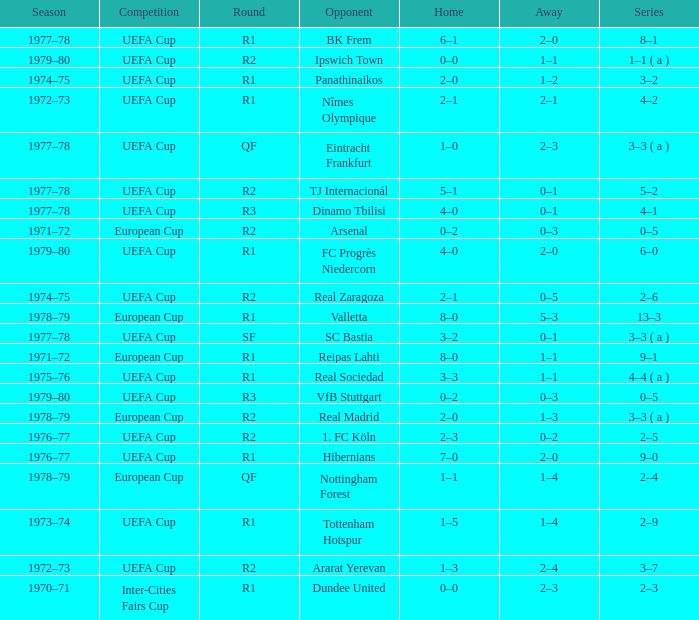Which Home has a Round of r1, and an Opponent of dundee united? 0–0. 